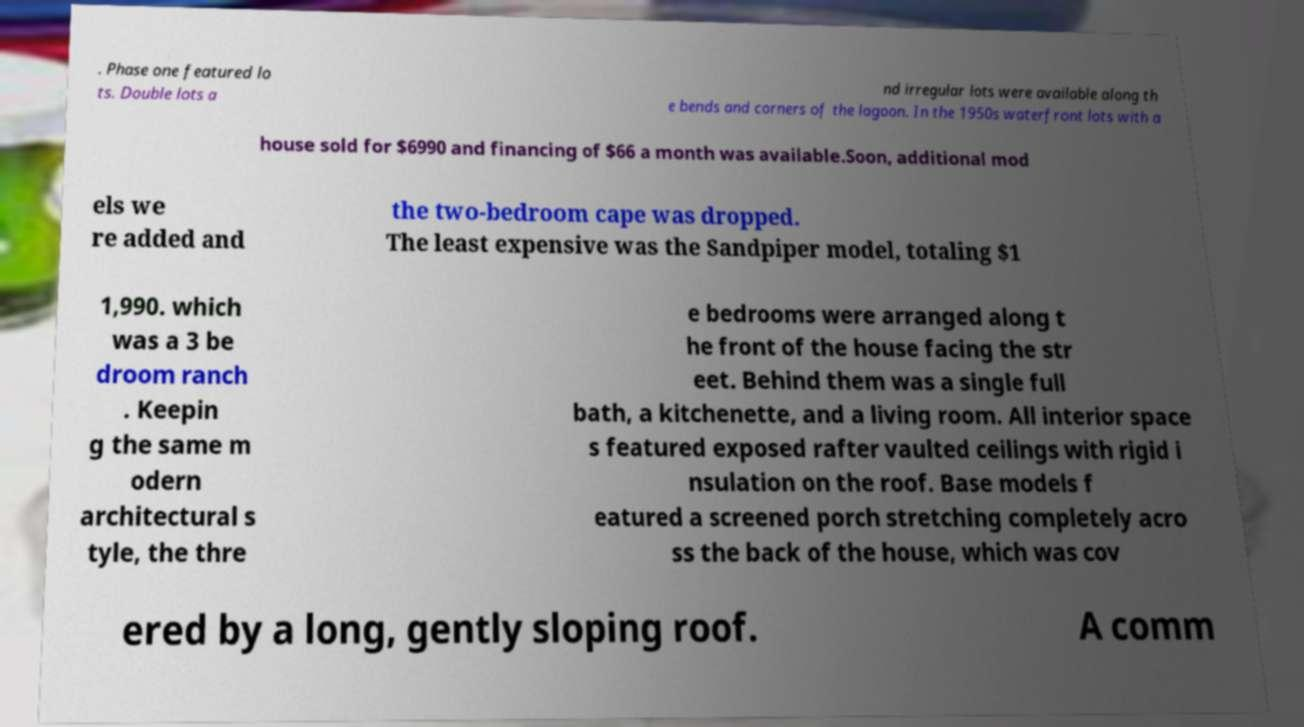There's text embedded in this image that I need extracted. Can you transcribe it verbatim? . Phase one featured lo ts. Double lots a nd irregular lots were available along th e bends and corners of the lagoon. In the 1950s waterfront lots with a house sold for $6990 and financing of $66 a month was available.Soon, additional mod els we re added and the two-bedroom cape was dropped. The least expensive was the Sandpiper model, totaling $1 1,990. which was a 3 be droom ranch . Keepin g the same m odern architectural s tyle, the thre e bedrooms were arranged along t he front of the house facing the str eet. Behind them was a single full bath, a kitchenette, and a living room. All interior space s featured exposed rafter vaulted ceilings with rigid i nsulation on the roof. Base models f eatured a screened porch stretching completely acro ss the back of the house, which was cov ered by a long, gently sloping roof. A comm 